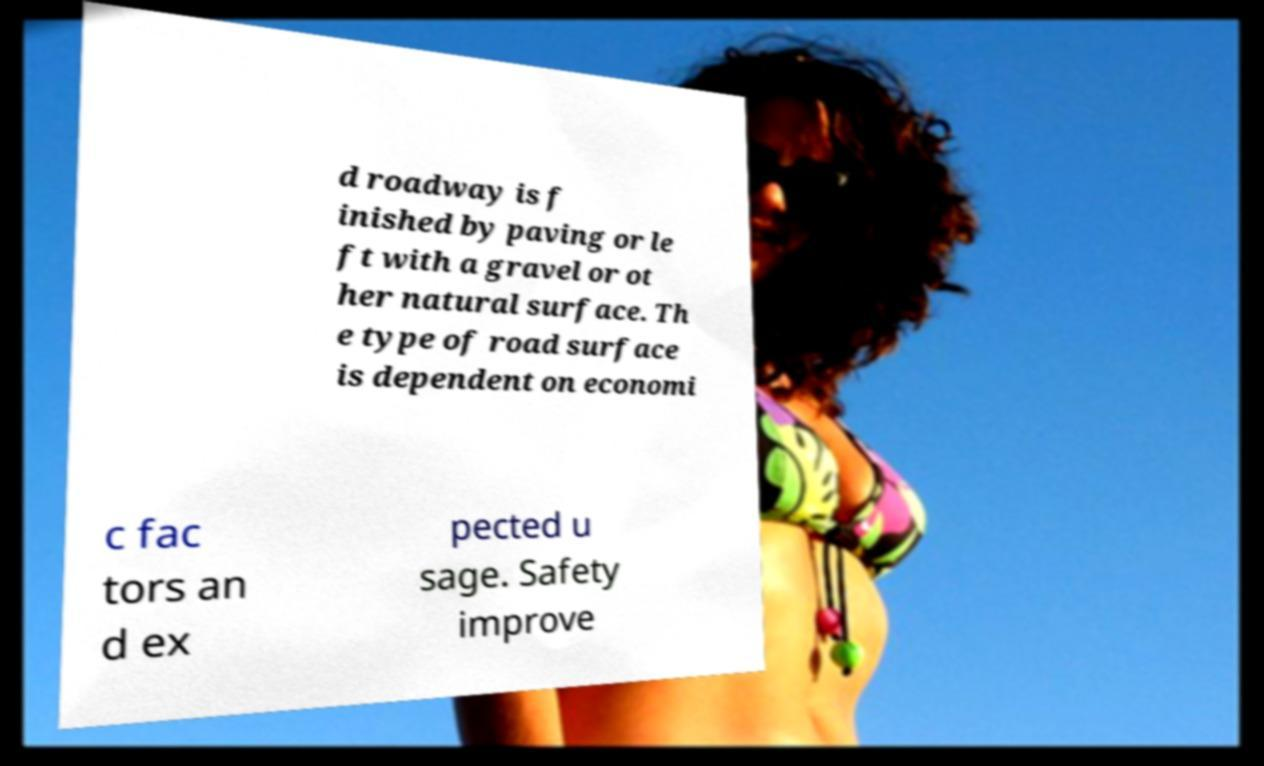Can you accurately transcribe the text from the provided image for me? d roadway is f inished by paving or le ft with a gravel or ot her natural surface. Th e type of road surface is dependent on economi c fac tors an d ex pected u sage. Safety improve 